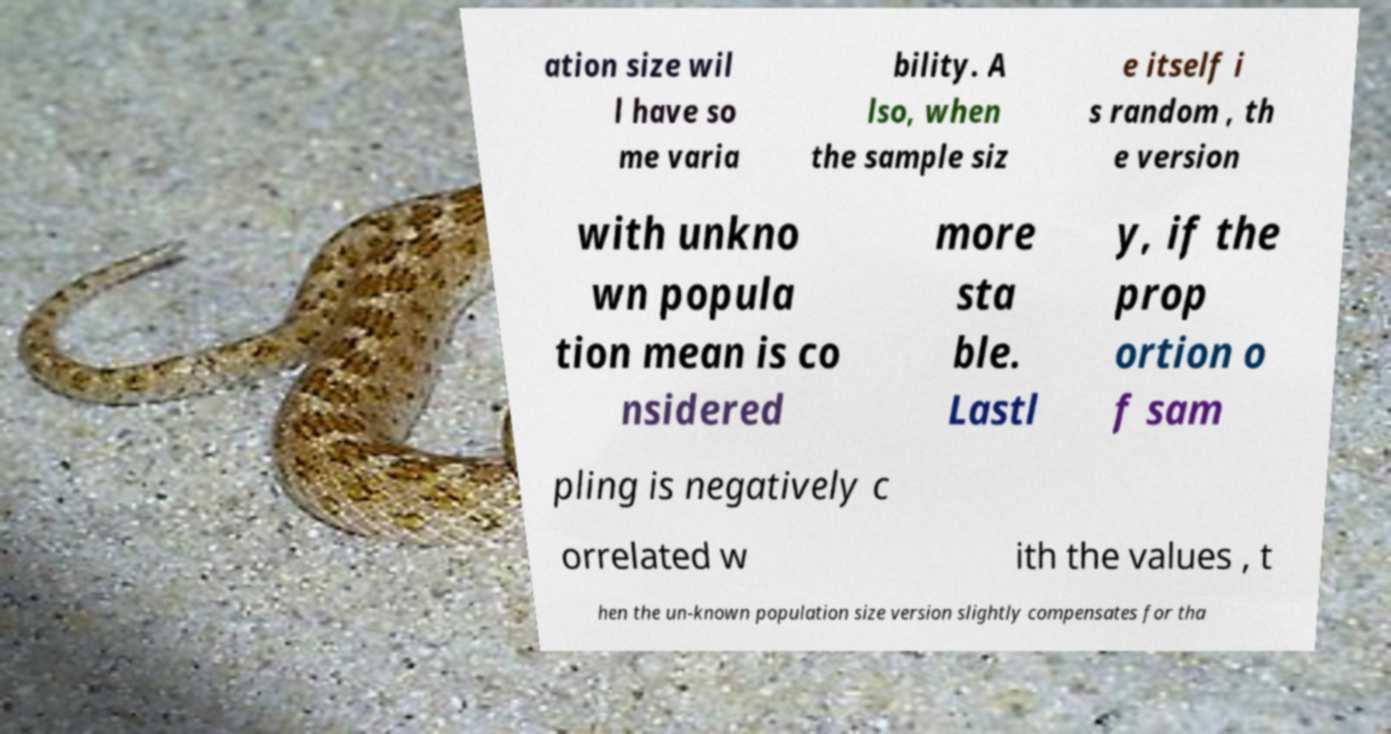There's text embedded in this image that I need extracted. Can you transcribe it verbatim? ation size wil l have so me varia bility. A lso, when the sample siz e itself i s random , th e version with unkno wn popula tion mean is co nsidered more sta ble. Lastl y, if the prop ortion o f sam pling is negatively c orrelated w ith the values , t hen the un-known population size version slightly compensates for tha 